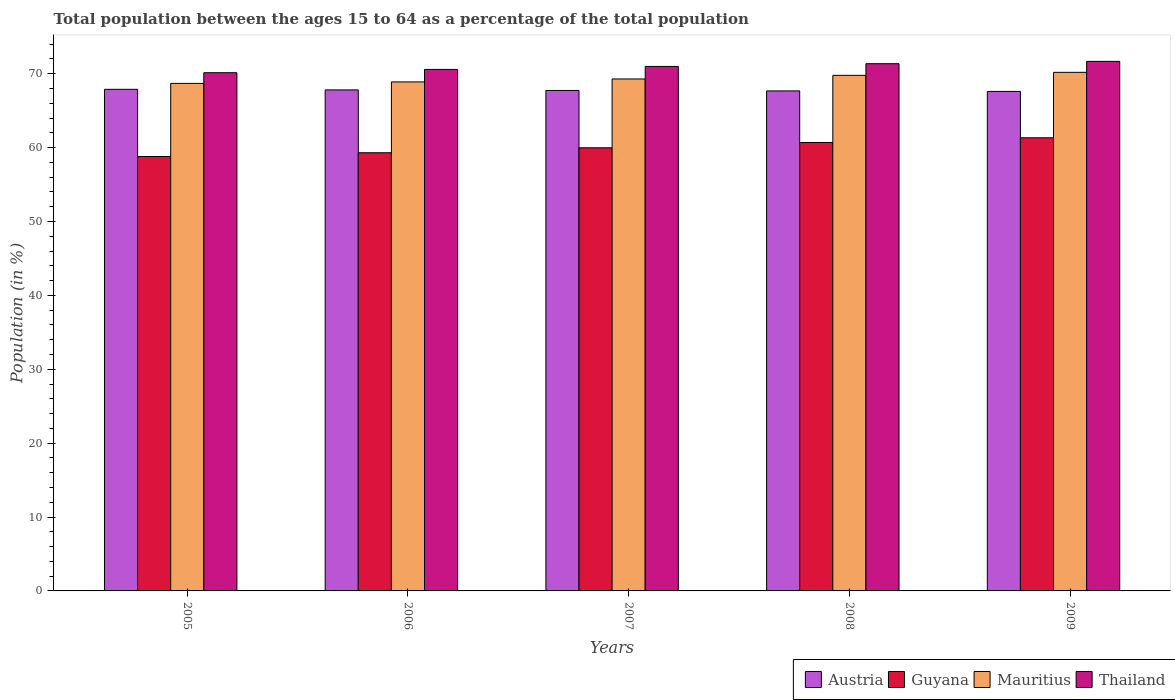How many different coloured bars are there?
Keep it short and to the point. 4. Are the number of bars per tick equal to the number of legend labels?
Offer a very short reply. Yes. How many bars are there on the 5th tick from the right?
Provide a succinct answer. 4. What is the label of the 1st group of bars from the left?
Offer a very short reply. 2005. In how many cases, is the number of bars for a given year not equal to the number of legend labels?
Your answer should be compact. 0. What is the percentage of the population ages 15 to 64 in Thailand in 2009?
Make the answer very short. 71.67. Across all years, what is the maximum percentage of the population ages 15 to 64 in Austria?
Provide a short and direct response. 67.88. Across all years, what is the minimum percentage of the population ages 15 to 64 in Thailand?
Offer a terse response. 70.13. In which year was the percentage of the population ages 15 to 64 in Mauritius maximum?
Offer a terse response. 2009. What is the total percentage of the population ages 15 to 64 in Guyana in the graph?
Your answer should be very brief. 300.07. What is the difference between the percentage of the population ages 15 to 64 in Austria in 2005 and that in 2008?
Offer a terse response. 0.22. What is the difference between the percentage of the population ages 15 to 64 in Thailand in 2007 and the percentage of the population ages 15 to 64 in Austria in 2009?
Your response must be concise. 3.38. What is the average percentage of the population ages 15 to 64 in Guyana per year?
Give a very brief answer. 60.01. In the year 2006, what is the difference between the percentage of the population ages 15 to 64 in Mauritius and percentage of the population ages 15 to 64 in Guyana?
Give a very brief answer. 9.59. What is the ratio of the percentage of the population ages 15 to 64 in Thailand in 2005 to that in 2008?
Make the answer very short. 0.98. Is the percentage of the population ages 15 to 64 in Mauritius in 2005 less than that in 2008?
Offer a terse response. Yes. What is the difference between the highest and the second highest percentage of the population ages 15 to 64 in Austria?
Make the answer very short. 0.08. What is the difference between the highest and the lowest percentage of the population ages 15 to 64 in Thailand?
Your answer should be very brief. 1.54. In how many years, is the percentage of the population ages 15 to 64 in Thailand greater than the average percentage of the population ages 15 to 64 in Thailand taken over all years?
Ensure brevity in your answer.  3. Is the sum of the percentage of the population ages 15 to 64 in Austria in 2007 and 2008 greater than the maximum percentage of the population ages 15 to 64 in Thailand across all years?
Your answer should be compact. Yes. Is it the case that in every year, the sum of the percentage of the population ages 15 to 64 in Mauritius and percentage of the population ages 15 to 64 in Guyana is greater than the sum of percentage of the population ages 15 to 64 in Thailand and percentage of the population ages 15 to 64 in Austria?
Your response must be concise. Yes. What does the 3rd bar from the left in 2005 represents?
Provide a short and direct response. Mauritius. What does the 1st bar from the right in 2005 represents?
Offer a very short reply. Thailand. Is it the case that in every year, the sum of the percentage of the population ages 15 to 64 in Guyana and percentage of the population ages 15 to 64 in Mauritius is greater than the percentage of the population ages 15 to 64 in Austria?
Offer a very short reply. Yes. How many bars are there?
Give a very brief answer. 20. How many years are there in the graph?
Provide a succinct answer. 5. Are the values on the major ticks of Y-axis written in scientific E-notation?
Provide a succinct answer. No. Does the graph contain any zero values?
Your answer should be very brief. No. Where does the legend appear in the graph?
Offer a terse response. Bottom right. How many legend labels are there?
Ensure brevity in your answer.  4. What is the title of the graph?
Your answer should be compact. Total population between the ages 15 to 64 as a percentage of the total population. What is the Population (in %) of Austria in 2005?
Your response must be concise. 67.88. What is the Population (in %) of Guyana in 2005?
Offer a terse response. 58.79. What is the Population (in %) of Mauritius in 2005?
Your response must be concise. 68.68. What is the Population (in %) of Thailand in 2005?
Provide a short and direct response. 70.13. What is the Population (in %) of Austria in 2006?
Provide a short and direct response. 67.81. What is the Population (in %) in Guyana in 2006?
Your answer should be very brief. 59.3. What is the Population (in %) in Mauritius in 2006?
Ensure brevity in your answer.  68.89. What is the Population (in %) of Thailand in 2006?
Provide a short and direct response. 70.58. What is the Population (in %) in Austria in 2007?
Provide a short and direct response. 67.73. What is the Population (in %) of Guyana in 2007?
Ensure brevity in your answer.  59.97. What is the Population (in %) in Mauritius in 2007?
Offer a very short reply. 69.29. What is the Population (in %) in Thailand in 2007?
Ensure brevity in your answer.  70.98. What is the Population (in %) in Austria in 2008?
Your answer should be very brief. 67.67. What is the Population (in %) in Guyana in 2008?
Give a very brief answer. 60.69. What is the Population (in %) of Mauritius in 2008?
Make the answer very short. 69.77. What is the Population (in %) of Thailand in 2008?
Offer a very short reply. 71.35. What is the Population (in %) of Austria in 2009?
Provide a succinct answer. 67.6. What is the Population (in %) in Guyana in 2009?
Offer a terse response. 61.33. What is the Population (in %) of Mauritius in 2009?
Your answer should be compact. 70.18. What is the Population (in %) of Thailand in 2009?
Provide a succinct answer. 71.67. Across all years, what is the maximum Population (in %) of Austria?
Your answer should be compact. 67.88. Across all years, what is the maximum Population (in %) in Guyana?
Provide a succinct answer. 61.33. Across all years, what is the maximum Population (in %) of Mauritius?
Give a very brief answer. 70.18. Across all years, what is the maximum Population (in %) of Thailand?
Your answer should be compact. 71.67. Across all years, what is the minimum Population (in %) in Austria?
Give a very brief answer. 67.6. Across all years, what is the minimum Population (in %) in Guyana?
Your answer should be compact. 58.79. Across all years, what is the minimum Population (in %) of Mauritius?
Give a very brief answer. 68.68. Across all years, what is the minimum Population (in %) in Thailand?
Your response must be concise. 70.13. What is the total Population (in %) of Austria in the graph?
Provide a short and direct response. 338.69. What is the total Population (in %) of Guyana in the graph?
Keep it short and to the point. 300.07. What is the total Population (in %) in Mauritius in the graph?
Ensure brevity in your answer.  346.81. What is the total Population (in %) of Thailand in the graph?
Offer a terse response. 354.71. What is the difference between the Population (in %) of Austria in 2005 and that in 2006?
Make the answer very short. 0.08. What is the difference between the Population (in %) of Guyana in 2005 and that in 2006?
Give a very brief answer. -0.51. What is the difference between the Population (in %) of Mauritius in 2005 and that in 2006?
Make the answer very short. -0.2. What is the difference between the Population (in %) of Thailand in 2005 and that in 2006?
Keep it short and to the point. -0.45. What is the difference between the Population (in %) in Austria in 2005 and that in 2007?
Provide a succinct answer. 0.15. What is the difference between the Population (in %) in Guyana in 2005 and that in 2007?
Your answer should be compact. -1.18. What is the difference between the Population (in %) in Mauritius in 2005 and that in 2007?
Offer a terse response. -0.6. What is the difference between the Population (in %) of Thailand in 2005 and that in 2007?
Provide a short and direct response. -0.85. What is the difference between the Population (in %) of Austria in 2005 and that in 2008?
Provide a succinct answer. 0.22. What is the difference between the Population (in %) in Guyana in 2005 and that in 2008?
Offer a terse response. -1.9. What is the difference between the Population (in %) of Mauritius in 2005 and that in 2008?
Keep it short and to the point. -1.09. What is the difference between the Population (in %) of Thailand in 2005 and that in 2008?
Your answer should be compact. -1.22. What is the difference between the Population (in %) of Austria in 2005 and that in 2009?
Give a very brief answer. 0.28. What is the difference between the Population (in %) in Guyana in 2005 and that in 2009?
Make the answer very short. -2.54. What is the difference between the Population (in %) of Mauritius in 2005 and that in 2009?
Offer a very short reply. -1.5. What is the difference between the Population (in %) in Thailand in 2005 and that in 2009?
Offer a terse response. -1.54. What is the difference between the Population (in %) of Austria in 2006 and that in 2007?
Ensure brevity in your answer.  0.07. What is the difference between the Population (in %) of Guyana in 2006 and that in 2007?
Your answer should be very brief. -0.67. What is the difference between the Population (in %) of Mauritius in 2006 and that in 2007?
Make the answer very short. -0.4. What is the difference between the Population (in %) in Thailand in 2006 and that in 2007?
Provide a succinct answer. -0.4. What is the difference between the Population (in %) in Austria in 2006 and that in 2008?
Keep it short and to the point. 0.14. What is the difference between the Population (in %) of Guyana in 2006 and that in 2008?
Make the answer very short. -1.39. What is the difference between the Population (in %) in Mauritius in 2006 and that in 2008?
Your answer should be very brief. -0.89. What is the difference between the Population (in %) in Thailand in 2006 and that in 2008?
Your answer should be compact. -0.77. What is the difference between the Population (in %) in Austria in 2006 and that in 2009?
Offer a very short reply. 0.21. What is the difference between the Population (in %) of Guyana in 2006 and that in 2009?
Make the answer very short. -2.03. What is the difference between the Population (in %) of Mauritius in 2006 and that in 2009?
Offer a very short reply. -1.3. What is the difference between the Population (in %) of Thailand in 2006 and that in 2009?
Give a very brief answer. -1.09. What is the difference between the Population (in %) in Austria in 2007 and that in 2008?
Offer a terse response. 0.07. What is the difference between the Population (in %) of Guyana in 2007 and that in 2008?
Give a very brief answer. -0.72. What is the difference between the Population (in %) of Mauritius in 2007 and that in 2008?
Ensure brevity in your answer.  -0.49. What is the difference between the Population (in %) in Thailand in 2007 and that in 2008?
Provide a short and direct response. -0.37. What is the difference between the Population (in %) in Austria in 2007 and that in 2009?
Provide a short and direct response. 0.13. What is the difference between the Population (in %) in Guyana in 2007 and that in 2009?
Provide a short and direct response. -1.36. What is the difference between the Population (in %) in Mauritius in 2007 and that in 2009?
Offer a very short reply. -0.9. What is the difference between the Population (in %) in Thailand in 2007 and that in 2009?
Provide a succinct answer. -0.69. What is the difference between the Population (in %) in Austria in 2008 and that in 2009?
Ensure brevity in your answer.  0.07. What is the difference between the Population (in %) in Guyana in 2008 and that in 2009?
Your answer should be compact. -0.64. What is the difference between the Population (in %) in Mauritius in 2008 and that in 2009?
Ensure brevity in your answer.  -0.41. What is the difference between the Population (in %) in Thailand in 2008 and that in 2009?
Provide a succinct answer. -0.32. What is the difference between the Population (in %) in Austria in 2005 and the Population (in %) in Guyana in 2006?
Your answer should be very brief. 8.59. What is the difference between the Population (in %) of Austria in 2005 and the Population (in %) of Mauritius in 2006?
Provide a succinct answer. -1. What is the difference between the Population (in %) of Austria in 2005 and the Population (in %) of Thailand in 2006?
Provide a succinct answer. -2.69. What is the difference between the Population (in %) in Guyana in 2005 and the Population (in %) in Mauritius in 2006?
Provide a succinct answer. -10.1. What is the difference between the Population (in %) of Guyana in 2005 and the Population (in %) of Thailand in 2006?
Make the answer very short. -11.79. What is the difference between the Population (in %) of Mauritius in 2005 and the Population (in %) of Thailand in 2006?
Your response must be concise. -1.89. What is the difference between the Population (in %) in Austria in 2005 and the Population (in %) in Guyana in 2007?
Your response must be concise. 7.91. What is the difference between the Population (in %) in Austria in 2005 and the Population (in %) in Mauritius in 2007?
Ensure brevity in your answer.  -1.4. What is the difference between the Population (in %) of Austria in 2005 and the Population (in %) of Thailand in 2007?
Provide a succinct answer. -3.1. What is the difference between the Population (in %) of Guyana in 2005 and the Population (in %) of Mauritius in 2007?
Ensure brevity in your answer.  -10.5. What is the difference between the Population (in %) of Guyana in 2005 and the Population (in %) of Thailand in 2007?
Give a very brief answer. -12.19. What is the difference between the Population (in %) in Mauritius in 2005 and the Population (in %) in Thailand in 2007?
Offer a terse response. -2.3. What is the difference between the Population (in %) in Austria in 2005 and the Population (in %) in Guyana in 2008?
Keep it short and to the point. 7.19. What is the difference between the Population (in %) in Austria in 2005 and the Population (in %) in Mauritius in 2008?
Your answer should be compact. -1.89. What is the difference between the Population (in %) in Austria in 2005 and the Population (in %) in Thailand in 2008?
Provide a succinct answer. -3.47. What is the difference between the Population (in %) in Guyana in 2005 and the Population (in %) in Mauritius in 2008?
Keep it short and to the point. -10.99. What is the difference between the Population (in %) of Guyana in 2005 and the Population (in %) of Thailand in 2008?
Your answer should be compact. -12.56. What is the difference between the Population (in %) of Mauritius in 2005 and the Population (in %) of Thailand in 2008?
Your answer should be very brief. -2.67. What is the difference between the Population (in %) of Austria in 2005 and the Population (in %) of Guyana in 2009?
Provide a succinct answer. 6.56. What is the difference between the Population (in %) of Austria in 2005 and the Population (in %) of Mauritius in 2009?
Ensure brevity in your answer.  -2.3. What is the difference between the Population (in %) in Austria in 2005 and the Population (in %) in Thailand in 2009?
Ensure brevity in your answer.  -3.78. What is the difference between the Population (in %) in Guyana in 2005 and the Population (in %) in Mauritius in 2009?
Offer a terse response. -11.39. What is the difference between the Population (in %) in Guyana in 2005 and the Population (in %) in Thailand in 2009?
Ensure brevity in your answer.  -12.88. What is the difference between the Population (in %) of Mauritius in 2005 and the Population (in %) of Thailand in 2009?
Give a very brief answer. -2.98. What is the difference between the Population (in %) in Austria in 2006 and the Population (in %) in Guyana in 2007?
Make the answer very short. 7.84. What is the difference between the Population (in %) in Austria in 2006 and the Population (in %) in Mauritius in 2007?
Give a very brief answer. -1.48. What is the difference between the Population (in %) in Austria in 2006 and the Population (in %) in Thailand in 2007?
Provide a succinct answer. -3.18. What is the difference between the Population (in %) of Guyana in 2006 and the Population (in %) of Mauritius in 2007?
Ensure brevity in your answer.  -9.99. What is the difference between the Population (in %) in Guyana in 2006 and the Population (in %) in Thailand in 2007?
Keep it short and to the point. -11.68. What is the difference between the Population (in %) of Mauritius in 2006 and the Population (in %) of Thailand in 2007?
Offer a very short reply. -2.1. What is the difference between the Population (in %) in Austria in 2006 and the Population (in %) in Guyana in 2008?
Your answer should be compact. 7.12. What is the difference between the Population (in %) of Austria in 2006 and the Population (in %) of Mauritius in 2008?
Offer a terse response. -1.97. What is the difference between the Population (in %) of Austria in 2006 and the Population (in %) of Thailand in 2008?
Provide a short and direct response. -3.55. What is the difference between the Population (in %) of Guyana in 2006 and the Population (in %) of Mauritius in 2008?
Offer a terse response. -10.47. What is the difference between the Population (in %) in Guyana in 2006 and the Population (in %) in Thailand in 2008?
Make the answer very short. -12.05. What is the difference between the Population (in %) of Mauritius in 2006 and the Population (in %) of Thailand in 2008?
Your answer should be very brief. -2.46. What is the difference between the Population (in %) in Austria in 2006 and the Population (in %) in Guyana in 2009?
Offer a very short reply. 6.48. What is the difference between the Population (in %) in Austria in 2006 and the Population (in %) in Mauritius in 2009?
Offer a terse response. -2.38. What is the difference between the Population (in %) in Austria in 2006 and the Population (in %) in Thailand in 2009?
Your response must be concise. -3.86. What is the difference between the Population (in %) in Guyana in 2006 and the Population (in %) in Mauritius in 2009?
Your answer should be compact. -10.88. What is the difference between the Population (in %) of Guyana in 2006 and the Population (in %) of Thailand in 2009?
Your answer should be very brief. -12.37. What is the difference between the Population (in %) of Mauritius in 2006 and the Population (in %) of Thailand in 2009?
Your response must be concise. -2.78. What is the difference between the Population (in %) of Austria in 2007 and the Population (in %) of Guyana in 2008?
Offer a very short reply. 7.04. What is the difference between the Population (in %) of Austria in 2007 and the Population (in %) of Mauritius in 2008?
Provide a succinct answer. -2.04. What is the difference between the Population (in %) of Austria in 2007 and the Population (in %) of Thailand in 2008?
Provide a succinct answer. -3.62. What is the difference between the Population (in %) of Guyana in 2007 and the Population (in %) of Mauritius in 2008?
Make the answer very short. -9.8. What is the difference between the Population (in %) of Guyana in 2007 and the Population (in %) of Thailand in 2008?
Offer a terse response. -11.38. What is the difference between the Population (in %) in Mauritius in 2007 and the Population (in %) in Thailand in 2008?
Provide a short and direct response. -2.07. What is the difference between the Population (in %) in Austria in 2007 and the Population (in %) in Guyana in 2009?
Offer a terse response. 6.41. What is the difference between the Population (in %) of Austria in 2007 and the Population (in %) of Mauritius in 2009?
Keep it short and to the point. -2.45. What is the difference between the Population (in %) in Austria in 2007 and the Population (in %) in Thailand in 2009?
Ensure brevity in your answer.  -3.94. What is the difference between the Population (in %) of Guyana in 2007 and the Population (in %) of Mauritius in 2009?
Your answer should be very brief. -10.21. What is the difference between the Population (in %) of Guyana in 2007 and the Population (in %) of Thailand in 2009?
Your answer should be compact. -11.7. What is the difference between the Population (in %) in Mauritius in 2007 and the Population (in %) in Thailand in 2009?
Offer a very short reply. -2.38. What is the difference between the Population (in %) in Austria in 2008 and the Population (in %) in Guyana in 2009?
Provide a succinct answer. 6.34. What is the difference between the Population (in %) in Austria in 2008 and the Population (in %) in Mauritius in 2009?
Offer a terse response. -2.52. What is the difference between the Population (in %) of Austria in 2008 and the Population (in %) of Thailand in 2009?
Keep it short and to the point. -4. What is the difference between the Population (in %) in Guyana in 2008 and the Population (in %) in Mauritius in 2009?
Offer a terse response. -9.49. What is the difference between the Population (in %) in Guyana in 2008 and the Population (in %) in Thailand in 2009?
Offer a very short reply. -10.98. What is the difference between the Population (in %) of Mauritius in 2008 and the Population (in %) of Thailand in 2009?
Make the answer very short. -1.89. What is the average Population (in %) in Austria per year?
Give a very brief answer. 67.74. What is the average Population (in %) in Guyana per year?
Ensure brevity in your answer.  60.01. What is the average Population (in %) of Mauritius per year?
Provide a succinct answer. 69.36. What is the average Population (in %) in Thailand per year?
Make the answer very short. 70.94. In the year 2005, what is the difference between the Population (in %) in Austria and Population (in %) in Guyana?
Keep it short and to the point. 9.1. In the year 2005, what is the difference between the Population (in %) in Austria and Population (in %) in Mauritius?
Make the answer very short. -0.8. In the year 2005, what is the difference between the Population (in %) of Austria and Population (in %) of Thailand?
Provide a succinct answer. -2.25. In the year 2005, what is the difference between the Population (in %) in Guyana and Population (in %) in Mauritius?
Offer a terse response. -9.9. In the year 2005, what is the difference between the Population (in %) in Guyana and Population (in %) in Thailand?
Make the answer very short. -11.34. In the year 2005, what is the difference between the Population (in %) of Mauritius and Population (in %) of Thailand?
Keep it short and to the point. -1.45. In the year 2006, what is the difference between the Population (in %) in Austria and Population (in %) in Guyana?
Provide a short and direct response. 8.51. In the year 2006, what is the difference between the Population (in %) in Austria and Population (in %) in Mauritius?
Offer a very short reply. -1.08. In the year 2006, what is the difference between the Population (in %) in Austria and Population (in %) in Thailand?
Provide a short and direct response. -2.77. In the year 2006, what is the difference between the Population (in %) in Guyana and Population (in %) in Mauritius?
Keep it short and to the point. -9.59. In the year 2006, what is the difference between the Population (in %) in Guyana and Population (in %) in Thailand?
Keep it short and to the point. -11.28. In the year 2006, what is the difference between the Population (in %) of Mauritius and Population (in %) of Thailand?
Provide a short and direct response. -1.69. In the year 2007, what is the difference between the Population (in %) of Austria and Population (in %) of Guyana?
Give a very brief answer. 7.76. In the year 2007, what is the difference between the Population (in %) of Austria and Population (in %) of Mauritius?
Ensure brevity in your answer.  -1.55. In the year 2007, what is the difference between the Population (in %) in Austria and Population (in %) in Thailand?
Offer a very short reply. -3.25. In the year 2007, what is the difference between the Population (in %) in Guyana and Population (in %) in Mauritius?
Offer a very short reply. -9.32. In the year 2007, what is the difference between the Population (in %) of Guyana and Population (in %) of Thailand?
Make the answer very short. -11.01. In the year 2007, what is the difference between the Population (in %) of Mauritius and Population (in %) of Thailand?
Your response must be concise. -1.7. In the year 2008, what is the difference between the Population (in %) in Austria and Population (in %) in Guyana?
Your answer should be compact. 6.98. In the year 2008, what is the difference between the Population (in %) in Austria and Population (in %) in Mauritius?
Ensure brevity in your answer.  -2.11. In the year 2008, what is the difference between the Population (in %) in Austria and Population (in %) in Thailand?
Your answer should be compact. -3.68. In the year 2008, what is the difference between the Population (in %) of Guyana and Population (in %) of Mauritius?
Your answer should be compact. -9.08. In the year 2008, what is the difference between the Population (in %) in Guyana and Population (in %) in Thailand?
Provide a short and direct response. -10.66. In the year 2008, what is the difference between the Population (in %) of Mauritius and Population (in %) of Thailand?
Give a very brief answer. -1.58. In the year 2009, what is the difference between the Population (in %) of Austria and Population (in %) of Guyana?
Give a very brief answer. 6.27. In the year 2009, what is the difference between the Population (in %) of Austria and Population (in %) of Mauritius?
Your answer should be very brief. -2.58. In the year 2009, what is the difference between the Population (in %) in Austria and Population (in %) in Thailand?
Your answer should be very brief. -4.07. In the year 2009, what is the difference between the Population (in %) in Guyana and Population (in %) in Mauritius?
Ensure brevity in your answer.  -8.86. In the year 2009, what is the difference between the Population (in %) in Guyana and Population (in %) in Thailand?
Your answer should be very brief. -10.34. In the year 2009, what is the difference between the Population (in %) of Mauritius and Population (in %) of Thailand?
Provide a short and direct response. -1.49. What is the ratio of the Population (in %) in Austria in 2005 to that in 2006?
Offer a very short reply. 1. What is the ratio of the Population (in %) of Guyana in 2005 to that in 2006?
Your response must be concise. 0.99. What is the ratio of the Population (in %) in Mauritius in 2005 to that in 2006?
Your response must be concise. 1. What is the ratio of the Population (in %) in Guyana in 2005 to that in 2007?
Offer a very short reply. 0.98. What is the ratio of the Population (in %) in Mauritius in 2005 to that in 2007?
Keep it short and to the point. 0.99. What is the ratio of the Population (in %) in Thailand in 2005 to that in 2007?
Give a very brief answer. 0.99. What is the ratio of the Population (in %) in Austria in 2005 to that in 2008?
Your answer should be compact. 1. What is the ratio of the Population (in %) in Guyana in 2005 to that in 2008?
Offer a very short reply. 0.97. What is the ratio of the Population (in %) in Mauritius in 2005 to that in 2008?
Offer a terse response. 0.98. What is the ratio of the Population (in %) in Thailand in 2005 to that in 2008?
Make the answer very short. 0.98. What is the ratio of the Population (in %) of Austria in 2005 to that in 2009?
Ensure brevity in your answer.  1. What is the ratio of the Population (in %) of Guyana in 2005 to that in 2009?
Your answer should be very brief. 0.96. What is the ratio of the Population (in %) of Mauritius in 2005 to that in 2009?
Offer a very short reply. 0.98. What is the ratio of the Population (in %) in Thailand in 2005 to that in 2009?
Your answer should be compact. 0.98. What is the ratio of the Population (in %) of Guyana in 2006 to that in 2007?
Provide a succinct answer. 0.99. What is the ratio of the Population (in %) in Thailand in 2006 to that in 2007?
Keep it short and to the point. 0.99. What is the ratio of the Population (in %) of Guyana in 2006 to that in 2008?
Keep it short and to the point. 0.98. What is the ratio of the Population (in %) in Mauritius in 2006 to that in 2008?
Your response must be concise. 0.99. What is the ratio of the Population (in %) of Austria in 2006 to that in 2009?
Keep it short and to the point. 1. What is the ratio of the Population (in %) in Mauritius in 2006 to that in 2009?
Your answer should be compact. 0.98. What is the ratio of the Population (in %) in Thailand in 2006 to that in 2009?
Offer a terse response. 0.98. What is the ratio of the Population (in %) in Mauritius in 2007 to that in 2008?
Make the answer very short. 0.99. What is the ratio of the Population (in %) of Austria in 2007 to that in 2009?
Offer a terse response. 1. What is the ratio of the Population (in %) in Guyana in 2007 to that in 2009?
Give a very brief answer. 0.98. What is the ratio of the Population (in %) of Mauritius in 2007 to that in 2009?
Offer a very short reply. 0.99. What is the ratio of the Population (in %) of Thailand in 2007 to that in 2009?
Give a very brief answer. 0.99. What is the ratio of the Population (in %) in Mauritius in 2008 to that in 2009?
Keep it short and to the point. 0.99. What is the ratio of the Population (in %) of Thailand in 2008 to that in 2009?
Offer a very short reply. 1. What is the difference between the highest and the second highest Population (in %) of Austria?
Your answer should be very brief. 0.08. What is the difference between the highest and the second highest Population (in %) of Guyana?
Your answer should be very brief. 0.64. What is the difference between the highest and the second highest Population (in %) of Mauritius?
Offer a terse response. 0.41. What is the difference between the highest and the second highest Population (in %) in Thailand?
Your response must be concise. 0.32. What is the difference between the highest and the lowest Population (in %) of Austria?
Give a very brief answer. 0.28. What is the difference between the highest and the lowest Population (in %) in Guyana?
Your answer should be very brief. 2.54. What is the difference between the highest and the lowest Population (in %) in Mauritius?
Give a very brief answer. 1.5. What is the difference between the highest and the lowest Population (in %) in Thailand?
Give a very brief answer. 1.54. 